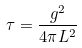<formula> <loc_0><loc_0><loc_500><loc_500>\tau = \frac { g ^ { 2 } } { 4 \pi L ^ { 2 } }</formula> 